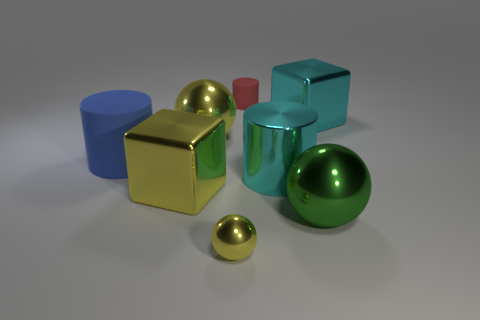Add 2 tiny red metal blocks. How many objects exist? 10 Subtract all cylinders. How many objects are left? 5 Add 6 big yellow blocks. How many big yellow blocks are left? 7 Add 2 tiny matte cylinders. How many tiny matte cylinders exist? 3 Subtract 0 brown balls. How many objects are left? 8 Subtract all red metallic blocks. Subtract all big cyan shiny cylinders. How many objects are left? 7 